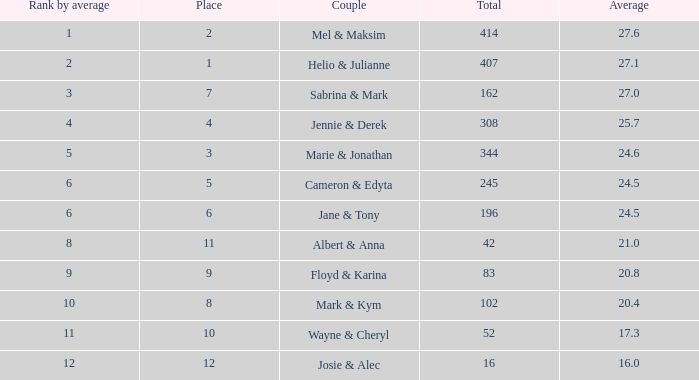What is the average place for a couple with the rank by average of 9 and total smaller than 83? None. 